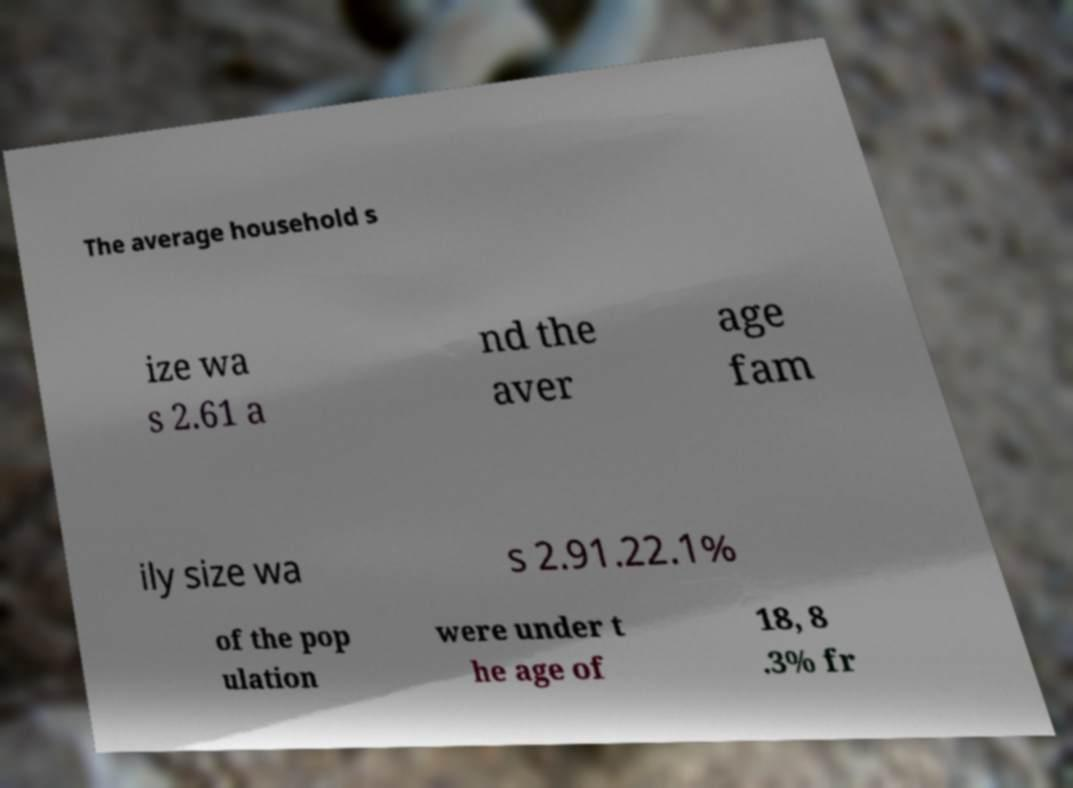Please identify and transcribe the text found in this image. The average household s ize wa s 2.61 a nd the aver age fam ily size wa s 2.91.22.1% of the pop ulation were under t he age of 18, 8 .3% fr 